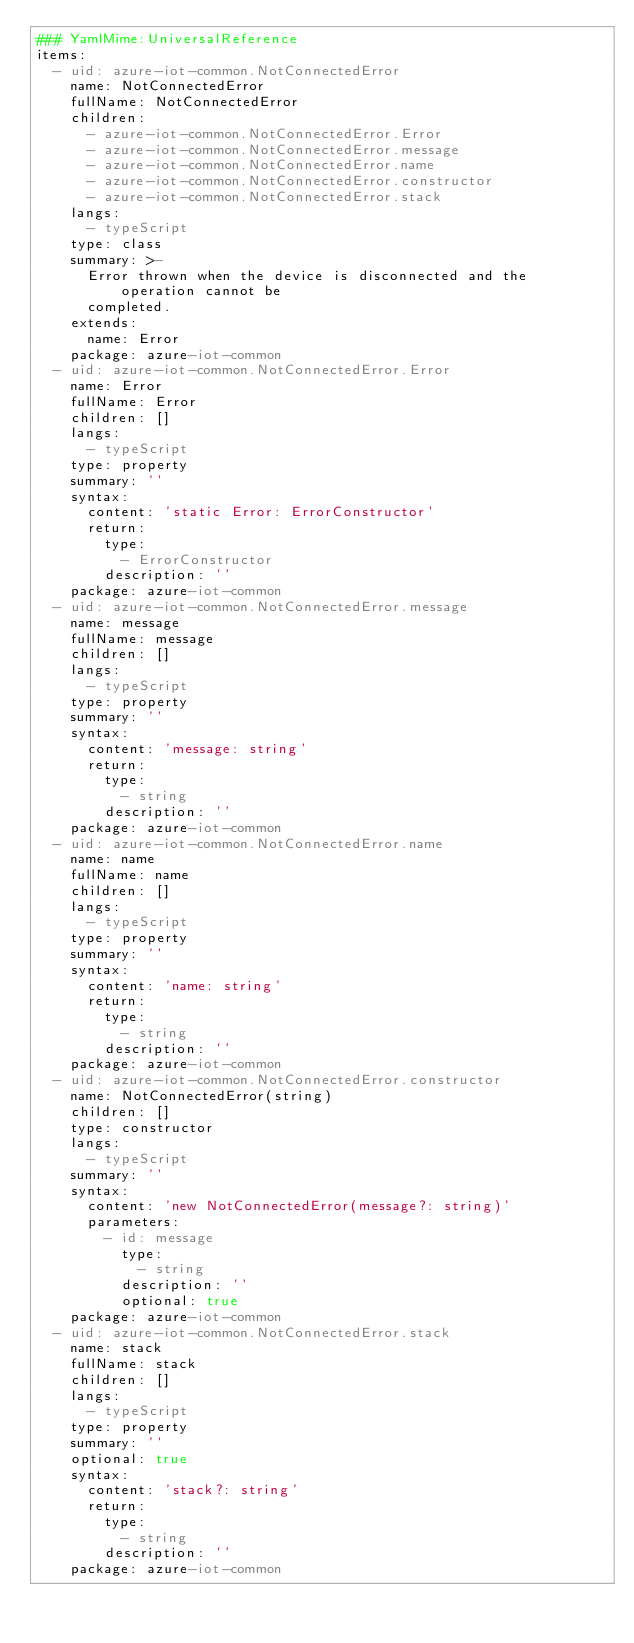Convert code to text. <code><loc_0><loc_0><loc_500><loc_500><_YAML_>### YamlMime:UniversalReference
items:
  - uid: azure-iot-common.NotConnectedError
    name: NotConnectedError
    fullName: NotConnectedError
    children:
      - azure-iot-common.NotConnectedError.Error
      - azure-iot-common.NotConnectedError.message
      - azure-iot-common.NotConnectedError.name
      - azure-iot-common.NotConnectedError.constructor
      - azure-iot-common.NotConnectedError.stack
    langs:
      - typeScript
    type: class
    summary: >-
      Error thrown when the device is disconnected and the operation cannot be
      completed.
    extends:
      name: Error
    package: azure-iot-common
  - uid: azure-iot-common.NotConnectedError.Error
    name: Error
    fullName: Error
    children: []
    langs:
      - typeScript
    type: property
    summary: ''
    syntax:
      content: 'static Error: ErrorConstructor'
      return:
        type:
          - ErrorConstructor
        description: ''
    package: azure-iot-common
  - uid: azure-iot-common.NotConnectedError.message
    name: message
    fullName: message
    children: []
    langs:
      - typeScript
    type: property
    summary: ''
    syntax:
      content: 'message: string'
      return:
        type:
          - string
        description: ''
    package: azure-iot-common
  - uid: azure-iot-common.NotConnectedError.name
    name: name
    fullName: name
    children: []
    langs:
      - typeScript
    type: property
    summary: ''
    syntax:
      content: 'name: string'
      return:
        type:
          - string
        description: ''
    package: azure-iot-common
  - uid: azure-iot-common.NotConnectedError.constructor
    name: NotConnectedError(string)
    children: []
    type: constructor
    langs:
      - typeScript
    summary: ''
    syntax:
      content: 'new NotConnectedError(message?: string)'
      parameters:
        - id: message
          type:
            - string
          description: ''
          optional: true
    package: azure-iot-common
  - uid: azure-iot-common.NotConnectedError.stack
    name: stack
    fullName: stack
    children: []
    langs:
      - typeScript
    type: property
    summary: ''
    optional: true
    syntax:
      content: 'stack?: string'
      return:
        type:
          - string
        description: ''
    package: azure-iot-common
</code> 